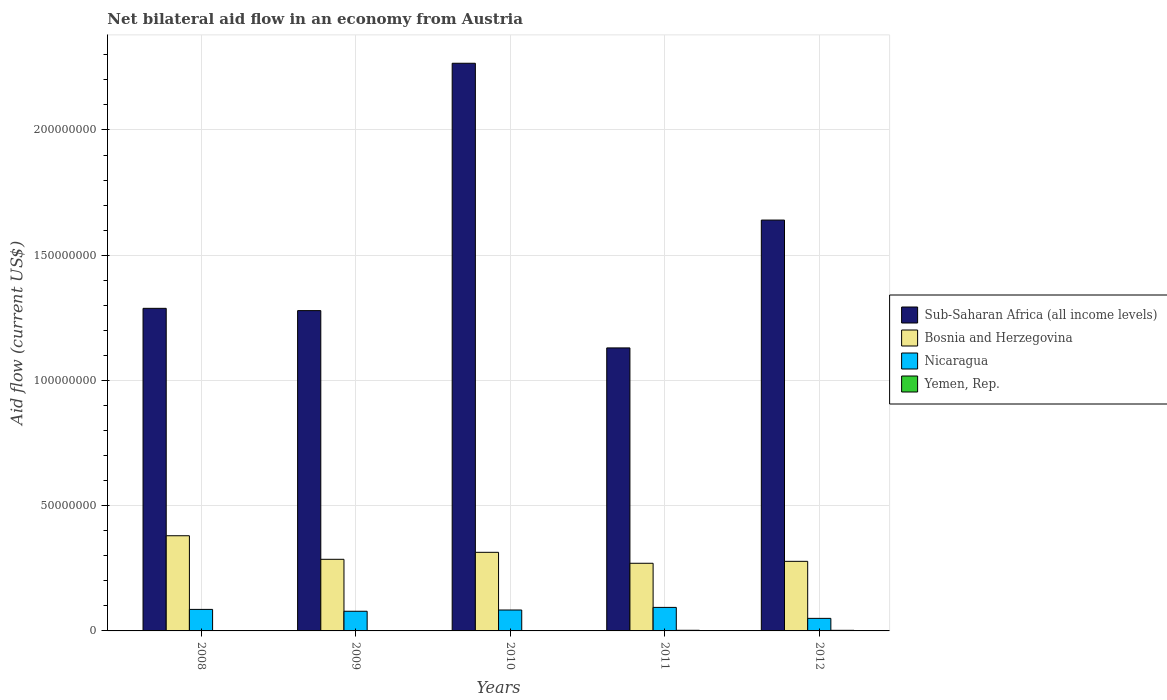What is the label of the 5th group of bars from the left?
Provide a short and direct response. 2012. In how many cases, is the number of bars for a given year not equal to the number of legend labels?
Make the answer very short. 0. What is the net bilateral aid flow in Nicaragua in 2010?
Your answer should be compact. 8.35e+06. Across all years, what is the maximum net bilateral aid flow in Sub-Saharan Africa (all income levels)?
Keep it short and to the point. 2.27e+08. Across all years, what is the minimum net bilateral aid flow in Sub-Saharan Africa (all income levels)?
Offer a terse response. 1.13e+08. In which year was the net bilateral aid flow in Yemen, Rep. maximum?
Make the answer very short. 2011. In which year was the net bilateral aid flow in Bosnia and Herzegovina minimum?
Offer a very short reply. 2011. What is the total net bilateral aid flow in Sub-Saharan Africa (all income levels) in the graph?
Your answer should be very brief. 7.60e+08. What is the difference between the net bilateral aid flow in Sub-Saharan Africa (all income levels) in 2009 and that in 2011?
Make the answer very short. 1.49e+07. What is the difference between the net bilateral aid flow in Nicaragua in 2008 and the net bilateral aid flow in Yemen, Rep. in 2010?
Your response must be concise. 8.57e+06. What is the average net bilateral aid flow in Sub-Saharan Africa (all income levels) per year?
Make the answer very short. 1.52e+08. In the year 2009, what is the difference between the net bilateral aid flow in Yemen, Rep. and net bilateral aid flow in Sub-Saharan Africa (all income levels)?
Ensure brevity in your answer.  -1.28e+08. What is the ratio of the net bilateral aid flow in Nicaragua in 2008 to that in 2012?
Offer a terse response. 1.71. Is the net bilateral aid flow in Sub-Saharan Africa (all income levels) in 2009 less than that in 2011?
Provide a succinct answer. No. What is the difference between the highest and the lowest net bilateral aid flow in Yemen, Rep.?
Provide a succinct answer. 2.30e+05. In how many years, is the net bilateral aid flow in Yemen, Rep. greater than the average net bilateral aid flow in Yemen, Rep. taken over all years?
Provide a succinct answer. 2. Is it the case that in every year, the sum of the net bilateral aid flow in Nicaragua and net bilateral aid flow in Bosnia and Herzegovina is greater than the sum of net bilateral aid flow in Sub-Saharan Africa (all income levels) and net bilateral aid flow in Yemen, Rep.?
Make the answer very short. No. What does the 3rd bar from the left in 2012 represents?
Give a very brief answer. Nicaragua. What does the 3rd bar from the right in 2009 represents?
Provide a short and direct response. Bosnia and Herzegovina. How many bars are there?
Ensure brevity in your answer.  20. Are all the bars in the graph horizontal?
Your response must be concise. No. How many years are there in the graph?
Ensure brevity in your answer.  5. Are the values on the major ticks of Y-axis written in scientific E-notation?
Provide a succinct answer. No. Does the graph contain grids?
Ensure brevity in your answer.  Yes. Where does the legend appear in the graph?
Offer a very short reply. Center right. How are the legend labels stacked?
Provide a short and direct response. Vertical. What is the title of the graph?
Ensure brevity in your answer.  Net bilateral aid flow in an economy from Austria. Does "Micronesia" appear as one of the legend labels in the graph?
Offer a terse response. No. What is the label or title of the X-axis?
Offer a terse response. Years. What is the label or title of the Y-axis?
Provide a short and direct response. Aid flow (current US$). What is the Aid flow (current US$) in Sub-Saharan Africa (all income levels) in 2008?
Offer a very short reply. 1.29e+08. What is the Aid flow (current US$) in Bosnia and Herzegovina in 2008?
Give a very brief answer. 3.80e+07. What is the Aid flow (current US$) of Nicaragua in 2008?
Ensure brevity in your answer.  8.59e+06. What is the Aid flow (current US$) in Yemen, Rep. in 2008?
Provide a succinct answer. 5.00e+04. What is the Aid flow (current US$) in Sub-Saharan Africa (all income levels) in 2009?
Your answer should be very brief. 1.28e+08. What is the Aid flow (current US$) of Bosnia and Herzegovina in 2009?
Offer a terse response. 2.86e+07. What is the Aid flow (current US$) of Nicaragua in 2009?
Provide a short and direct response. 7.85e+06. What is the Aid flow (current US$) of Sub-Saharan Africa (all income levels) in 2010?
Your answer should be compact. 2.27e+08. What is the Aid flow (current US$) in Bosnia and Herzegovina in 2010?
Ensure brevity in your answer.  3.14e+07. What is the Aid flow (current US$) of Nicaragua in 2010?
Offer a very short reply. 8.35e+06. What is the Aid flow (current US$) in Yemen, Rep. in 2010?
Your answer should be very brief. 2.00e+04. What is the Aid flow (current US$) in Sub-Saharan Africa (all income levels) in 2011?
Give a very brief answer. 1.13e+08. What is the Aid flow (current US$) of Bosnia and Herzegovina in 2011?
Give a very brief answer. 2.70e+07. What is the Aid flow (current US$) of Nicaragua in 2011?
Make the answer very short. 9.39e+06. What is the Aid flow (current US$) in Yemen, Rep. in 2011?
Keep it short and to the point. 2.50e+05. What is the Aid flow (current US$) of Sub-Saharan Africa (all income levels) in 2012?
Provide a succinct answer. 1.64e+08. What is the Aid flow (current US$) in Bosnia and Herzegovina in 2012?
Your response must be concise. 2.78e+07. What is the Aid flow (current US$) in Nicaragua in 2012?
Your answer should be very brief. 5.01e+06. Across all years, what is the maximum Aid flow (current US$) in Sub-Saharan Africa (all income levels)?
Provide a short and direct response. 2.27e+08. Across all years, what is the maximum Aid flow (current US$) in Bosnia and Herzegovina?
Keep it short and to the point. 3.80e+07. Across all years, what is the maximum Aid flow (current US$) in Nicaragua?
Offer a very short reply. 9.39e+06. Across all years, what is the maximum Aid flow (current US$) of Yemen, Rep.?
Offer a terse response. 2.50e+05. Across all years, what is the minimum Aid flow (current US$) of Sub-Saharan Africa (all income levels)?
Keep it short and to the point. 1.13e+08. Across all years, what is the minimum Aid flow (current US$) of Bosnia and Herzegovina?
Your response must be concise. 2.70e+07. Across all years, what is the minimum Aid flow (current US$) in Nicaragua?
Your answer should be compact. 5.01e+06. Across all years, what is the minimum Aid flow (current US$) in Yemen, Rep.?
Your answer should be compact. 2.00e+04. What is the total Aid flow (current US$) in Sub-Saharan Africa (all income levels) in the graph?
Offer a terse response. 7.60e+08. What is the total Aid flow (current US$) in Bosnia and Herzegovina in the graph?
Keep it short and to the point. 1.53e+08. What is the total Aid flow (current US$) in Nicaragua in the graph?
Offer a very short reply. 3.92e+07. What is the total Aid flow (current US$) of Yemen, Rep. in the graph?
Your response must be concise. 5.90e+05. What is the difference between the Aid flow (current US$) of Sub-Saharan Africa (all income levels) in 2008 and that in 2009?
Provide a short and direct response. 9.10e+05. What is the difference between the Aid flow (current US$) of Bosnia and Herzegovina in 2008 and that in 2009?
Offer a terse response. 9.41e+06. What is the difference between the Aid flow (current US$) in Nicaragua in 2008 and that in 2009?
Give a very brief answer. 7.40e+05. What is the difference between the Aid flow (current US$) of Sub-Saharan Africa (all income levels) in 2008 and that in 2010?
Ensure brevity in your answer.  -9.78e+07. What is the difference between the Aid flow (current US$) in Bosnia and Herzegovina in 2008 and that in 2010?
Offer a very short reply. 6.62e+06. What is the difference between the Aid flow (current US$) of Nicaragua in 2008 and that in 2010?
Give a very brief answer. 2.40e+05. What is the difference between the Aid flow (current US$) of Yemen, Rep. in 2008 and that in 2010?
Provide a succinct answer. 3.00e+04. What is the difference between the Aid flow (current US$) of Sub-Saharan Africa (all income levels) in 2008 and that in 2011?
Keep it short and to the point. 1.58e+07. What is the difference between the Aid flow (current US$) in Bosnia and Herzegovina in 2008 and that in 2011?
Your answer should be compact. 1.10e+07. What is the difference between the Aid flow (current US$) of Nicaragua in 2008 and that in 2011?
Provide a succinct answer. -8.00e+05. What is the difference between the Aid flow (current US$) in Yemen, Rep. in 2008 and that in 2011?
Your response must be concise. -2.00e+05. What is the difference between the Aid flow (current US$) of Sub-Saharan Africa (all income levels) in 2008 and that in 2012?
Provide a succinct answer. -3.52e+07. What is the difference between the Aid flow (current US$) of Bosnia and Herzegovina in 2008 and that in 2012?
Make the answer very short. 1.02e+07. What is the difference between the Aid flow (current US$) in Nicaragua in 2008 and that in 2012?
Provide a succinct answer. 3.58e+06. What is the difference between the Aid flow (current US$) in Sub-Saharan Africa (all income levels) in 2009 and that in 2010?
Make the answer very short. -9.88e+07. What is the difference between the Aid flow (current US$) of Bosnia and Herzegovina in 2009 and that in 2010?
Make the answer very short. -2.79e+06. What is the difference between the Aid flow (current US$) of Nicaragua in 2009 and that in 2010?
Provide a short and direct response. -5.00e+05. What is the difference between the Aid flow (current US$) in Sub-Saharan Africa (all income levels) in 2009 and that in 2011?
Give a very brief answer. 1.49e+07. What is the difference between the Aid flow (current US$) of Bosnia and Herzegovina in 2009 and that in 2011?
Give a very brief answer. 1.58e+06. What is the difference between the Aid flow (current US$) in Nicaragua in 2009 and that in 2011?
Your answer should be very brief. -1.54e+06. What is the difference between the Aid flow (current US$) of Sub-Saharan Africa (all income levels) in 2009 and that in 2012?
Provide a short and direct response. -3.62e+07. What is the difference between the Aid flow (current US$) in Bosnia and Herzegovina in 2009 and that in 2012?
Keep it short and to the point. 8.10e+05. What is the difference between the Aid flow (current US$) in Nicaragua in 2009 and that in 2012?
Ensure brevity in your answer.  2.84e+06. What is the difference between the Aid flow (current US$) in Yemen, Rep. in 2009 and that in 2012?
Make the answer very short. -2.10e+05. What is the difference between the Aid flow (current US$) in Sub-Saharan Africa (all income levels) in 2010 and that in 2011?
Your answer should be very brief. 1.14e+08. What is the difference between the Aid flow (current US$) of Bosnia and Herzegovina in 2010 and that in 2011?
Keep it short and to the point. 4.37e+06. What is the difference between the Aid flow (current US$) in Nicaragua in 2010 and that in 2011?
Your response must be concise. -1.04e+06. What is the difference between the Aid flow (current US$) in Yemen, Rep. in 2010 and that in 2011?
Provide a succinct answer. -2.30e+05. What is the difference between the Aid flow (current US$) of Sub-Saharan Africa (all income levels) in 2010 and that in 2012?
Your answer should be compact. 6.26e+07. What is the difference between the Aid flow (current US$) of Bosnia and Herzegovina in 2010 and that in 2012?
Your response must be concise. 3.60e+06. What is the difference between the Aid flow (current US$) in Nicaragua in 2010 and that in 2012?
Offer a terse response. 3.34e+06. What is the difference between the Aid flow (current US$) of Sub-Saharan Africa (all income levels) in 2011 and that in 2012?
Provide a short and direct response. -5.10e+07. What is the difference between the Aid flow (current US$) of Bosnia and Herzegovina in 2011 and that in 2012?
Make the answer very short. -7.70e+05. What is the difference between the Aid flow (current US$) of Nicaragua in 2011 and that in 2012?
Make the answer very short. 4.38e+06. What is the difference between the Aid flow (current US$) in Sub-Saharan Africa (all income levels) in 2008 and the Aid flow (current US$) in Bosnia and Herzegovina in 2009?
Give a very brief answer. 1.00e+08. What is the difference between the Aid flow (current US$) in Sub-Saharan Africa (all income levels) in 2008 and the Aid flow (current US$) in Nicaragua in 2009?
Keep it short and to the point. 1.21e+08. What is the difference between the Aid flow (current US$) in Sub-Saharan Africa (all income levels) in 2008 and the Aid flow (current US$) in Yemen, Rep. in 2009?
Give a very brief answer. 1.29e+08. What is the difference between the Aid flow (current US$) of Bosnia and Herzegovina in 2008 and the Aid flow (current US$) of Nicaragua in 2009?
Provide a succinct answer. 3.02e+07. What is the difference between the Aid flow (current US$) of Bosnia and Herzegovina in 2008 and the Aid flow (current US$) of Yemen, Rep. in 2009?
Provide a short and direct response. 3.80e+07. What is the difference between the Aid flow (current US$) in Nicaragua in 2008 and the Aid flow (current US$) in Yemen, Rep. in 2009?
Offer a terse response. 8.56e+06. What is the difference between the Aid flow (current US$) of Sub-Saharan Africa (all income levels) in 2008 and the Aid flow (current US$) of Bosnia and Herzegovina in 2010?
Offer a terse response. 9.74e+07. What is the difference between the Aid flow (current US$) of Sub-Saharan Africa (all income levels) in 2008 and the Aid flow (current US$) of Nicaragua in 2010?
Give a very brief answer. 1.20e+08. What is the difference between the Aid flow (current US$) in Sub-Saharan Africa (all income levels) in 2008 and the Aid flow (current US$) in Yemen, Rep. in 2010?
Make the answer very short. 1.29e+08. What is the difference between the Aid flow (current US$) of Bosnia and Herzegovina in 2008 and the Aid flow (current US$) of Nicaragua in 2010?
Offer a terse response. 2.96e+07. What is the difference between the Aid flow (current US$) in Bosnia and Herzegovina in 2008 and the Aid flow (current US$) in Yemen, Rep. in 2010?
Ensure brevity in your answer.  3.80e+07. What is the difference between the Aid flow (current US$) in Nicaragua in 2008 and the Aid flow (current US$) in Yemen, Rep. in 2010?
Offer a terse response. 8.57e+06. What is the difference between the Aid flow (current US$) in Sub-Saharan Africa (all income levels) in 2008 and the Aid flow (current US$) in Bosnia and Herzegovina in 2011?
Your response must be concise. 1.02e+08. What is the difference between the Aid flow (current US$) of Sub-Saharan Africa (all income levels) in 2008 and the Aid flow (current US$) of Nicaragua in 2011?
Give a very brief answer. 1.19e+08. What is the difference between the Aid flow (current US$) of Sub-Saharan Africa (all income levels) in 2008 and the Aid flow (current US$) of Yemen, Rep. in 2011?
Your answer should be compact. 1.29e+08. What is the difference between the Aid flow (current US$) of Bosnia and Herzegovina in 2008 and the Aid flow (current US$) of Nicaragua in 2011?
Give a very brief answer. 2.86e+07. What is the difference between the Aid flow (current US$) of Bosnia and Herzegovina in 2008 and the Aid flow (current US$) of Yemen, Rep. in 2011?
Your response must be concise. 3.78e+07. What is the difference between the Aid flow (current US$) in Nicaragua in 2008 and the Aid flow (current US$) in Yemen, Rep. in 2011?
Your response must be concise. 8.34e+06. What is the difference between the Aid flow (current US$) of Sub-Saharan Africa (all income levels) in 2008 and the Aid flow (current US$) of Bosnia and Herzegovina in 2012?
Make the answer very short. 1.01e+08. What is the difference between the Aid flow (current US$) in Sub-Saharan Africa (all income levels) in 2008 and the Aid flow (current US$) in Nicaragua in 2012?
Your response must be concise. 1.24e+08. What is the difference between the Aid flow (current US$) in Sub-Saharan Africa (all income levels) in 2008 and the Aid flow (current US$) in Yemen, Rep. in 2012?
Keep it short and to the point. 1.29e+08. What is the difference between the Aid flow (current US$) of Bosnia and Herzegovina in 2008 and the Aid flow (current US$) of Nicaragua in 2012?
Offer a very short reply. 3.30e+07. What is the difference between the Aid flow (current US$) in Bosnia and Herzegovina in 2008 and the Aid flow (current US$) in Yemen, Rep. in 2012?
Provide a short and direct response. 3.78e+07. What is the difference between the Aid flow (current US$) of Nicaragua in 2008 and the Aid flow (current US$) of Yemen, Rep. in 2012?
Make the answer very short. 8.35e+06. What is the difference between the Aid flow (current US$) of Sub-Saharan Africa (all income levels) in 2009 and the Aid flow (current US$) of Bosnia and Herzegovina in 2010?
Make the answer very short. 9.65e+07. What is the difference between the Aid flow (current US$) in Sub-Saharan Africa (all income levels) in 2009 and the Aid flow (current US$) in Nicaragua in 2010?
Offer a very short reply. 1.20e+08. What is the difference between the Aid flow (current US$) of Sub-Saharan Africa (all income levels) in 2009 and the Aid flow (current US$) of Yemen, Rep. in 2010?
Provide a succinct answer. 1.28e+08. What is the difference between the Aid flow (current US$) in Bosnia and Herzegovina in 2009 and the Aid flow (current US$) in Nicaragua in 2010?
Offer a very short reply. 2.02e+07. What is the difference between the Aid flow (current US$) in Bosnia and Herzegovina in 2009 and the Aid flow (current US$) in Yemen, Rep. in 2010?
Your response must be concise. 2.86e+07. What is the difference between the Aid flow (current US$) in Nicaragua in 2009 and the Aid flow (current US$) in Yemen, Rep. in 2010?
Your answer should be very brief. 7.83e+06. What is the difference between the Aid flow (current US$) of Sub-Saharan Africa (all income levels) in 2009 and the Aid flow (current US$) of Bosnia and Herzegovina in 2011?
Give a very brief answer. 1.01e+08. What is the difference between the Aid flow (current US$) of Sub-Saharan Africa (all income levels) in 2009 and the Aid flow (current US$) of Nicaragua in 2011?
Ensure brevity in your answer.  1.18e+08. What is the difference between the Aid flow (current US$) of Sub-Saharan Africa (all income levels) in 2009 and the Aid flow (current US$) of Yemen, Rep. in 2011?
Offer a very short reply. 1.28e+08. What is the difference between the Aid flow (current US$) of Bosnia and Herzegovina in 2009 and the Aid flow (current US$) of Nicaragua in 2011?
Offer a very short reply. 1.92e+07. What is the difference between the Aid flow (current US$) in Bosnia and Herzegovina in 2009 and the Aid flow (current US$) in Yemen, Rep. in 2011?
Ensure brevity in your answer.  2.83e+07. What is the difference between the Aid flow (current US$) in Nicaragua in 2009 and the Aid flow (current US$) in Yemen, Rep. in 2011?
Your answer should be compact. 7.60e+06. What is the difference between the Aid flow (current US$) of Sub-Saharan Africa (all income levels) in 2009 and the Aid flow (current US$) of Bosnia and Herzegovina in 2012?
Offer a very short reply. 1.00e+08. What is the difference between the Aid flow (current US$) in Sub-Saharan Africa (all income levels) in 2009 and the Aid flow (current US$) in Nicaragua in 2012?
Keep it short and to the point. 1.23e+08. What is the difference between the Aid flow (current US$) of Sub-Saharan Africa (all income levels) in 2009 and the Aid flow (current US$) of Yemen, Rep. in 2012?
Offer a terse response. 1.28e+08. What is the difference between the Aid flow (current US$) in Bosnia and Herzegovina in 2009 and the Aid flow (current US$) in Nicaragua in 2012?
Your response must be concise. 2.36e+07. What is the difference between the Aid flow (current US$) in Bosnia and Herzegovina in 2009 and the Aid flow (current US$) in Yemen, Rep. in 2012?
Keep it short and to the point. 2.84e+07. What is the difference between the Aid flow (current US$) of Nicaragua in 2009 and the Aid flow (current US$) of Yemen, Rep. in 2012?
Ensure brevity in your answer.  7.61e+06. What is the difference between the Aid flow (current US$) of Sub-Saharan Africa (all income levels) in 2010 and the Aid flow (current US$) of Bosnia and Herzegovina in 2011?
Make the answer very short. 2.00e+08. What is the difference between the Aid flow (current US$) of Sub-Saharan Africa (all income levels) in 2010 and the Aid flow (current US$) of Nicaragua in 2011?
Provide a short and direct response. 2.17e+08. What is the difference between the Aid flow (current US$) of Sub-Saharan Africa (all income levels) in 2010 and the Aid flow (current US$) of Yemen, Rep. in 2011?
Keep it short and to the point. 2.26e+08. What is the difference between the Aid flow (current US$) in Bosnia and Herzegovina in 2010 and the Aid flow (current US$) in Nicaragua in 2011?
Offer a very short reply. 2.20e+07. What is the difference between the Aid flow (current US$) in Bosnia and Herzegovina in 2010 and the Aid flow (current US$) in Yemen, Rep. in 2011?
Offer a terse response. 3.11e+07. What is the difference between the Aid flow (current US$) of Nicaragua in 2010 and the Aid flow (current US$) of Yemen, Rep. in 2011?
Give a very brief answer. 8.10e+06. What is the difference between the Aid flow (current US$) of Sub-Saharan Africa (all income levels) in 2010 and the Aid flow (current US$) of Bosnia and Herzegovina in 2012?
Your answer should be compact. 1.99e+08. What is the difference between the Aid flow (current US$) of Sub-Saharan Africa (all income levels) in 2010 and the Aid flow (current US$) of Nicaragua in 2012?
Provide a succinct answer. 2.22e+08. What is the difference between the Aid flow (current US$) in Sub-Saharan Africa (all income levels) in 2010 and the Aid flow (current US$) in Yemen, Rep. in 2012?
Your response must be concise. 2.26e+08. What is the difference between the Aid flow (current US$) of Bosnia and Herzegovina in 2010 and the Aid flow (current US$) of Nicaragua in 2012?
Ensure brevity in your answer.  2.64e+07. What is the difference between the Aid flow (current US$) of Bosnia and Herzegovina in 2010 and the Aid flow (current US$) of Yemen, Rep. in 2012?
Offer a very short reply. 3.11e+07. What is the difference between the Aid flow (current US$) in Nicaragua in 2010 and the Aid flow (current US$) in Yemen, Rep. in 2012?
Your answer should be compact. 8.11e+06. What is the difference between the Aid flow (current US$) of Sub-Saharan Africa (all income levels) in 2011 and the Aid flow (current US$) of Bosnia and Herzegovina in 2012?
Provide a succinct answer. 8.52e+07. What is the difference between the Aid flow (current US$) in Sub-Saharan Africa (all income levels) in 2011 and the Aid flow (current US$) in Nicaragua in 2012?
Your response must be concise. 1.08e+08. What is the difference between the Aid flow (current US$) of Sub-Saharan Africa (all income levels) in 2011 and the Aid flow (current US$) of Yemen, Rep. in 2012?
Keep it short and to the point. 1.13e+08. What is the difference between the Aid flow (current US$) of Bosnia and Herzegovina in 2011 and the Aid flow (current US$) of Nicaragua in 2012?
Your answer should be very brief. 2.20e+07. What is the difference between the Aid flow (current US$) in Bosnia and Herzegovina in 2011 and the Aid flow (current US$) in Yemen, Rep. in 2012?
Your answer should be very brief. 2.68e+07. What is the difference between the Aid flow (current US$) in Nicaragua in 2011 and the Aid flow (current US$) in Yemen, Rep. in 2012?
Offer a very short reply. 9.15e+06. What is the average Aid flow (current US$) of Sub-Saharan Africa (all income levels) per year?
Your answer should be compact. 1.52e+08. What is the average Aid flow (current US$) of Bosnia and Herzegovina per year?
Keep it short and to the point. 3.06e+07. What is the average Aid flow (current US$) of Nicaragua per year?
Offer a very short reply. 7.84e+06. What is the average Aid flow (current US$) in Yemen, Rep. per year?
Make the answer very short. 1.18e+05. In the year 2008, what is the difference between the Aid flow (current US$) in Sub-Saharan Africa (all income levels) and Aid flow (current US$) in Bosnia and Herzegovina?
Provide a short and direct response. 9.08e+07. In the year 2008, what is the difference between the Aid flow (current US$) of Sub-Saharan Africa (all income levels) and Aid flow (current US$) of Nicaragua?
Your answer should be compact. 1.20e+08. In the year 2008, what is the difference between the Aid flow (current US$) of Sub-Saharan Africa (all income levels) and Aid flow (current US$) of Yemen, Rep.?
Offer a terse response. 1.29e+08. In the year 2008, what is the difference between the Aid flow (current US$) in Bosnia and Herzegovina and Aid flow (current US$) in Nicaragua?
Give a very brief answer. 2.94e+07. In the year 2008, what is the difference between the Aid flow (current US$) of Bosnia and Herzegovina and Aid flow (current US$) of Yemen, Rep.?
Keep it short and to the point. 3.80e+07. In the year 2008, what is the difference between the Aid flow (current US$) of Nicaragua and Aid flow (current US$) of Yemen, Rep.?
Make the answer very short. 8.54e+06. In the year 2009, what is the difference between the Aid flow (current US$) in Sub-Saharan Africa (all income levels) and Aid flow (current US$) in Bosnia and Herzegovina?
Provide a succinct answer. 9.93e+07. In the year 2009, what is the difference between the Aid flow (current US$) of Sub-Saharan Africa (all income levels) and Aid flow (current US$) of Nicaragua?
Provide a short and direct response. 1.20e+08. In the year 2009, what is the difference between the Aid flow (current US$) in Sub-Saharan Africa (all income levels) and Aid flow (current US$) in Yemen, Rep.?
Provide a short and direct response. 1.28e+08. In the year 2009, what is the difference between the Aid flow (current US$) in Bosnia and Herzegovina and Aid flow (current US$) in Nicaragua?
Ensure brevity in your answer.  2.07e+07. In the year 2009, what is the difference between the Aid flow (current US$) of Bosnia and Herzegovina and Aid flow (current US$) of Yemen, Rep.?
Provide a succinct answer. 2.86e+07. In the year 2009, what is the difference between the Aid flow (current US$) of Nicaragua and Aid flow (current US$) of Yemen, Rep.?
Ensure brevity in your answer.  7.82e+06. In the year 2010, what is the difference between the Aid flow (current US$) in Sub-Saharan Africa (all income levels) and Aid flow (current US$) in Bosnia and Herzegovina?
Offer a very short reply. 1.95e+08. In the year 2010, what is the difference between the Aid flow (current US$) of Sub-Saharan Africa (all income levels) and Aid flow (current US$) of Nicaragua?
Give a very brief answer. 2.18e+08. In the year 2010, what is the difference between the Aid flow (current US$) of Sub-Saharan Africa (all income levels) and Aid flow (current US$) of Yemen, Rep.?
Offer a terse response. 2.27e+08. In the year 2010, what is the difference between the Aid flow (current US$) in Bosnia and Herzegovina and Aid flow (current US$) in Nicaragua?
Give a very brief answer. 2.30e+07. In the year 2010, what is the difference between the Aid flow (current US$) of Bosnia and Herzegovina and Aid flow (current US$) of Yemen, Rep.?
Make the answer very short. 3.14e+07. In the year 2010, what is the difference between the Aid flow (current US$) in Nicaragua and Aid flow (current US$) in Yemen, Rep.?
Your answer should be very brief. 8.33e+06. In the year 2011, what is the difference between the Aid flow (current US$) of Sub-Saharan Africa (all income levels) and Aid flow (current US$) of Bosnia and Herzegovina?
Make the answer very short. 8.60e+07. In the year 2011, what is the difference between the Aid flow (current US$) in Sub-Saharan Africa (all income levels) and Aid flow (current US$) in Nicaragua?
Your answer should be very brief. 1.04e+08. In the year 2011, what is the difference between the Aid flow (current US$) in Sub-Saharan Africa (all income levels) and Aid flow (current US$) in Yemen, Rep.?
Give a very brief answer. 1.13e+08. In the year 2011, what is the difference between the Aid flow (current US$) in Bosnia and Herzegovina and Aid flow (current US$) in Nicaragua?
Your response must be concise. 1.76e+07. In the year 2011, what is the difference between the Aid flow (current US$) of Bosnia and Herzegovina and Aid flow (current US$) of Yemen, Rep.?
Your response must be concise. 2.68e+07. In the year 2011, what is the difference between the Aid flow (current US$) of Nicaragua and Aid flow (current US$) of Yemen, Rep.?
Make the answer very short. 9.14e+06. In the year 2012, what is the difference between the Aid flow (current US$) in Sub-Saharan Africa (all income levels) and Aid flow (current US$) in Bosnia and Herzegovina?
Ensure brevity in your answer.  1.36e+08. In the year 2012, what is the difference between the Aid flow (current US$) in Sub-Saharan Africa (all income levels) and Aid flow (current US$) in Nicaragua?
Offer a terse response. 1.59e+08. In the year 2012, what is the difference between the Aid flow (current US$) of Sub-Saharan Africa (all income levels) and Aid flow (current US$) of Yemen, Rep.?
Your response must be concise. 1.64e+08. In the year 2012, what is the difference between the Aid flow (current US$) in Bosnia and Herzegovina and Aid flow (current US$) in Nicaragua?
Your response must be concise. 2.28e+07. In the year 2012, what is the difference between the Aid flow (current US$) of Bosnia and Herzegovina and Aid flow (current US$) of Yemen, Rep.?
Keep it short and to the point. 2.75e+07. In the year 2012, what is the difference between the Aid flow (current US$) of Nicaragua and Aid flow (current US$) of Yemen, Rep.?
Provide a short and direct response. 4.77e+06. What is the ratio of the Aid flow (current US$) in Sub-Saharan Africa (all income levels) in 2008 to that in 2009?
Your answer should be very brief. 1.01. What is the ratio of the Aid flow (current US$) of Bosnia and Herzegovina in 2008 to that in 2009?
Offer a very short reply. 1.33. What is the ratio of the Aid flow (current US$) in Nicaragua in 2008 to that in 2009?
Offer a very short reply. 1.09. What is the ratio of the Aid flow (current US$) in Yemen, Rep. in 2008 to that in 2009?
Your answer should be compact. 1.67. What is the ratio of the Aid flow (current US$) in Sub-Saharan Africa (all income levels) in 2008 to that in 2010?
Offer a terse response. 0.57. What is the ratio of the Aid flow (current US$) in Bosnia and Herzegovina in 2008 to that in 2010?
Provide a short and direct response. 1.21. What is the ratio of the Aid flow (current US$) of Nicaragua in 2008 to that in 2010?
Offer a very short reply. 1.03. What is the ratio of the Aid flow (current US$) in Yemen, Rep. in 2008 to that in 2010?
Offer a terse response. 2.5. What is the ratio of the Aid flow (current US$) in Sub-Saharan Africa (all income levels) in 2008 to that in 2011?
Provide a succinct answer. 1.14. What is the ratio of the Aid flow (current US$) of Bosnia and Herzegovina in 2008 to that in 2011?
Provide a succinct answer. 1.41. What is the ratio of the Aid flow (current US$) in Nicaragua in 2008 to that in 2011?
Your answer should be compact. 0.91. What is the ratio of the Aid flow (current US$) of Sub-Saharan Africa (all income levels) in 2008 to that in 2012?
Your response must be concise. 0.79. What is the ratio of the Aid flow (current US$) of Bosnia and Herzegovina in 2008 to that in 2012?
Make the answer very short. 1.37. What is the ratio of the Aid flow (current US$) of Nicaragua in 2008 to that in 2012?
Ensure brevity in your answer.  1.71. What is the ratio of the Aid flow (current US$) of Yemen, Rep. in 2008 to that in 2012?
Offer a terse response. 0.21. What is the ratio of the Aid flow (current US$) of Sub-Saharan Africa (all income levels) in 2009 to that in 2010?
Your response must be concise. 0.56. What is the ratio of the Aid flow (current US$) in Bosnia and Herzegovina in 2009 to that in 2010?
Your answer should be compact. 0.91. What is the ratio of the Aid flow (current US$) in Nicaragua in 2009 to that in 2010?
Your answer should be compact. 0.94. What is the ratio of the Aid flow (current US$) in Yemen, Rep. in 2009 to that in 2010?
Make the answer very short. 1.5. What is the ratio of the Aid flow (current US$) in Sub-Saharan Africa (all income levels) in 2009 to that in 2011?
Offer a very short reply. 1.13. What is the ratio of the Aid flow (current US$) of Bosnia and Herzegovina in 2009 to that in 2011?
Your response must be concise. 1.06. What is the ratio of the Aid flow (current US$) of Nicaragua in 2009 to that in 2011?
Provide a succinct answer. 0.84. What is the ratio of the Aid flow (current US$) of Yemen, Rep. in 2009 to that in 2011?
Keep it short and to the point. 0.12. What is the ratio of the Aid flow (current US$) of Sub-Saharan Africa (all income levels) in 2009 to that in 2012?
Your answer should be very brief. 0.78. What is the ratio of the Aid flow (current US$) of Bosnia and Herzegovina in 2009 to that in 2012?
Your answer should be very brief. 1.03. What is the ratio of the Aid flow (current US$) in Nicaragua in 2009 to that in 2012?
Provide a succinct answer. 1.57. What is the ratio of the Aid flow (current US$) in Yemen, Rep. in 2009 to that in 2012?
Your response must be concise. 0.12. What is the ratio of the Aid flow (current US$) of Sub-Saharan Africa (all income levels) in 2010 to that in 2011?
Provide a short and direct response. 2.01. What is the ratio of the Aid flow (current US$) of Bosnia and Herzegovina in 2010 to that in 2011?
Offer a terse response. 1.16. What is the ratio of the Aid flow (current US$) of Nicaragua in 2010 to that in 2011?
Your answer should be very brief. 0.89. What is the ratio of the Aid flow (current US$) in Sub-Saharan Africa (all income levels) in 2010 to that in 2012?
Your answer should be very brief. 1.38. What is the ratio of the Aid flow (current US$) in Bosnia and Herzegovina in 2010 to that in 2012?
Keep it short and to the point. 1.13. What is the ratio of the Aid flow (current US$) in Nicaragua in 2010 to that in 2012?
Your response must be concise. 1.67. What is the ratio of the Aid flow (current US$) in Yemen, Rep. in 2010 to that in 2012?
Keep it short and to the point. 0.08. What is the ratio of the Aid flow (current US$) of Sub-Saharan Africa (all income levels) in 2011 to that in 2012?
Ensure brevity in your answer.  0.69. What is the ratio of the Aid flow (current US$) in Bosnia and Herzegovina in 2011 to that in 2012?
Provide a short and direct response. 0.97. What is the ratio of the Aid flow (current US$) of Nicaragua in 2011 to that in 2012?
Provide a short and direct response. 1.87. What is the ratio of the Aid flow (current US$) in Yemen, Rep. in 2011 to that in 2012?
Provide a succinct answer. 1.04. What is the difference between the highest and the second highest Aid flow (current US$) of Sub-Saharan Africa (all income levels)?
Ensure brevity in your answer.  6.26e+07. What is the difference between the highest and the second highest Aid flow (current US$) of Bosnia and Herzegovina?
Offer a very short reply. 6.62e+06. What is the difference between the highest and the second highest Aid flow (current US$) of Nicaragua?
Make the answer very short. 8.00e+05. What is the difference between the highest and the second highest Aid flow (current US$) of Yemen, Rep.?
Your answer should be very brief. 10000. What is the difference between the highest and the lowest Aid flow (current US$) of Sub-Saharan Africa (all income levels)?
Offer a very short reply. 1.14e+08. What is the difference between the highest and the lowest Aid flow (current US$) of Bosnia and Herzegovina?
Your response must be concise. 1.10e+07. What is the difference between the highest and the lowest Aid flow (current US$) of Nicaragua?
Your answer should be very brief. 4.38e+06. What is the difference between the highest and the lowest Aid flow (current US$) of Yemen, Rep.?
Offer a terse response. 2.30e+05. 